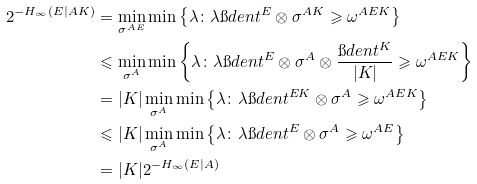Convert formula to latex. <formula><loc_0><loc_0><loc_500><loc_500>2 ^ { - H _ { \infty } ( E | A K ) } & = \min _ { \sigma ^ { A E } } \min \left \{ \lambda \colon \lambda \i d e n t ^ { E } \otimes \sigma ^ { A K } \geqslant \omega ^ { A E K } \right \} \\ & \leqslant \min _ { \sigma ^ { A } } \min \left \{ \lambda \colon \lambda \i d e n t ^ { E } \otimes \sigma ^ { A } \otimes \frac { \i d e n t ^ { K } } { | K | } \geqslant \omega ^ { A E K } \right \} \\ & = | K | \min _ { \sigma ^ { A } } \min \left \{ \lambda \colon \lambda \i d e n t ^ { E K } \otimes \sigma ^ { A } \geqslant \omega ^ { A E K } \right \} \\ & \leqslant | K | \min _ { \sigma ^ { A } } \min \left \{ \lambda \colon \lambda \i d e n t ^ { E } \otimes \sigma ^ { A } \geqslant \omega ^ { A E } \right \} \\ & = | K | 2 ^ { - H _ { \infty } ( E | A ) }</formula> 